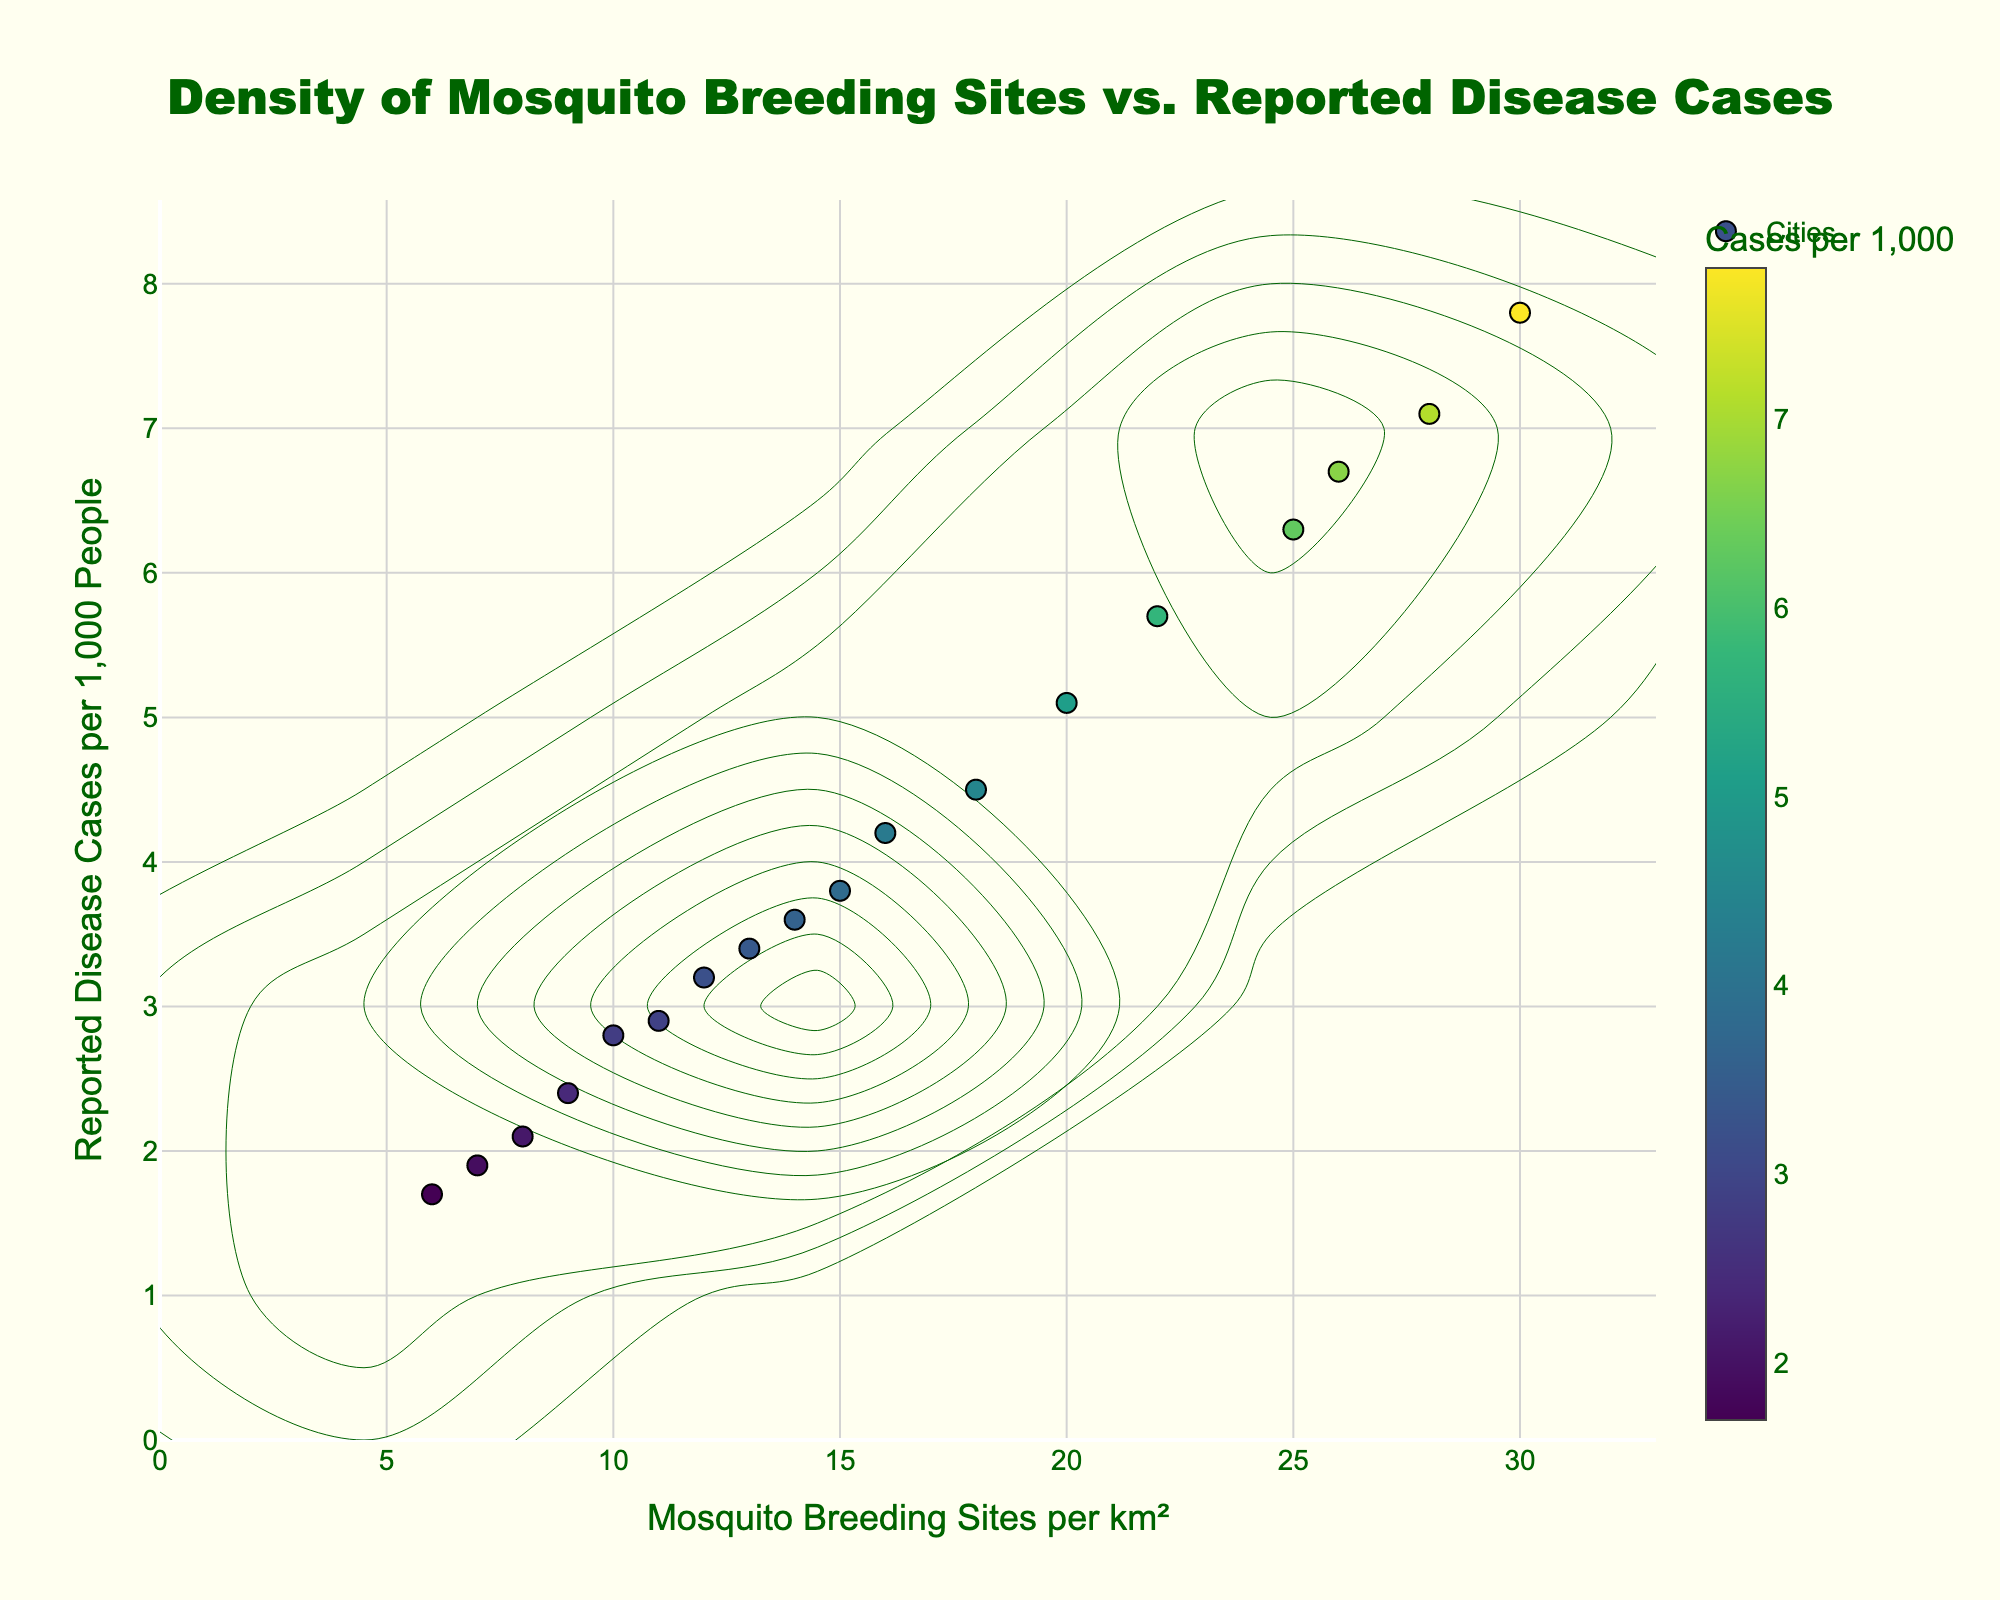How many data points are shown in the plot? The plot shows one data point per city. By counting the cities listed in the data, we can see there are 18 cities.
Answer: 18 Which city has the highest density of mosquito breeding sites per km²? By looking at the scatter plot, we see that the highest density of mosquito breeding sites per km² is 30, which corresponds to the city of Bangkok (13.7563, 100.5018).
Answer: Bangkok What is the correlation between mosquito breeding sites and reported disease cases? The density plot shows a positive correlation; as the number of mosquito breeding sites per km² increases, reported disease cases per 1000 people also tend to increase.
Answer: Positive correlation Identify the city with the lowest number of reported disease cases per 1000 people. By examining the scatter plot, we see that the lowest reported cases are 1.7, which corresponds to Berlin (52.5200, 13.4050).
Answer: Berlin Compare the number of reported cases between Tokyo and Sydney. Which city has more reported cases per 1000 people? Tokyo has 6.3 reported cases per 1000 people, whereas Sydney has 2.9 reported cases. Therefore, Tokyo has more reported cases.
Answer: Tokyo What range of mosquito breeding sites per km² is most associated with 5-7 reported disease cases per 1000 people? Looking at the density contours, the range most associated with 5-7 reported cases per 1000 people is 22 to 30 mosquito breeding sites per km².
Answer: 22-30 Which data point has the largest marker size, and what does this signify? The marker size relates to the reported disease cases per 1000 people. The largest marker size corresponds to the highest reported cases, which is 7.8 in Bangkok (13.7563, 100.5018).
Answer: Bangkok, 7.8 How many cities have over 20 mosquito breeding sites per km²? By counting the scatter points above the 20 breeding sites per km² line, we see that there are 4 cities: Houston, Atlanta, Bangkok, and Singapore.
Answer: 4 Is there any city with fewer than 10 mosquito breeding sites per km²? If yes, name it. Yes, there are cities with fewer than 10 mosquito breeding sites per km². Specifically, Paris (7) and Berlin (6).
Answer: Paris and Berlin What is the general trend observed in the scatter plot between mosquito breeding sites and disease cases? The general trend observed is that as the density of mosquito breeding sites per km² increases, the number of reported disease cases per 1000 people tends to increase.
Answer: Increasing trend 